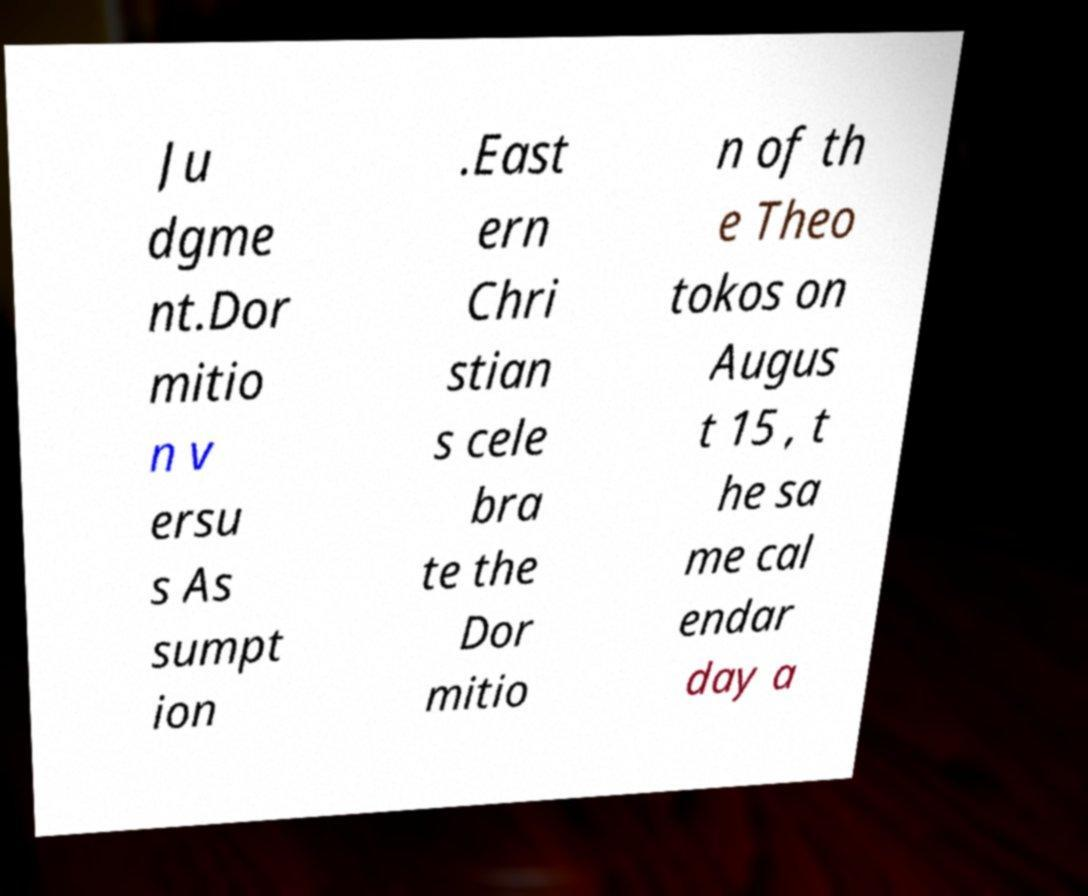Can you accurately transcribe the text from the provided image for me? Ju dgme nt.Dor mitio n v ersu s As sumpt ion .East ern Chri stian s cele bra te the Dor mitio n of th e Theo tokos on Augus t 15 , t he sa me cal endar day a 